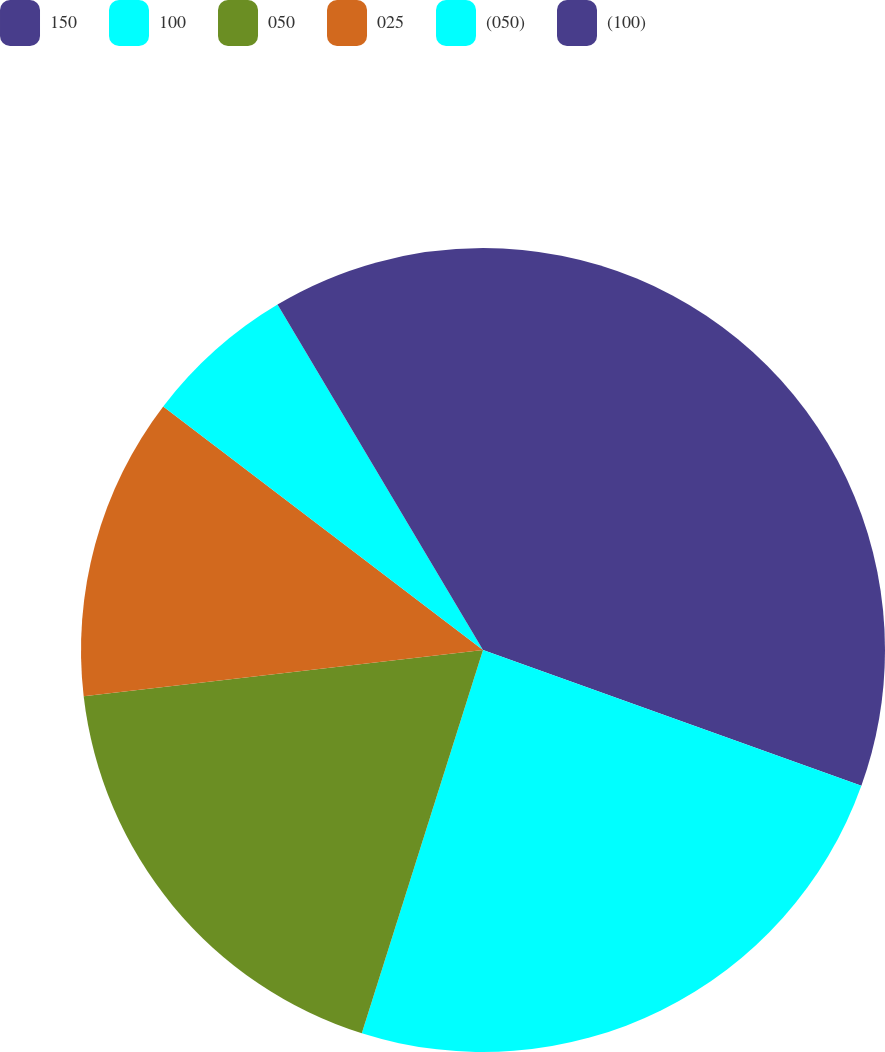<chart> <loc_0><loc_0><loc_500><loc_500><pie_chart><fcel>150<fcel>100<fcel>050<fcel>025<fcel>(050)<fcel>(100)<nl><fcel>30.49%<fcel>24.39%<fcel>18.29%<fcel>12.2%<fcel>6.1%<fcel>8.54%<nl></chart> 